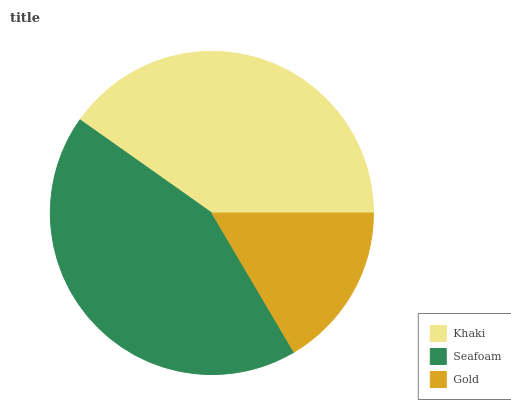Is Gold the minimum?
Answer yes or no. Yes. Is Seafoam the maximum?
Answer yes or no. Yes. Is Seafoam the minimum?
Answer yes or no. No. Is Gold the maximum?
Answer yes or no. No. Is Seafoam greater than Gold?
Answer yes or no. Yes. Is Gold less than Seafoam?
Answer yes or no. Yes. Is Gold greater than Seafoam?
Answer yes or no. No. Is Seafoam less than Gold?
Answer yes or no. No. Is Khaki the high median?
Answer yes or no. Yes. Is Khaki the low median?
Answer yes or no. Yes. Is Gold the high median?
Answer yes or no. No. Is Gold the low median?
Answer yes or no. No. 